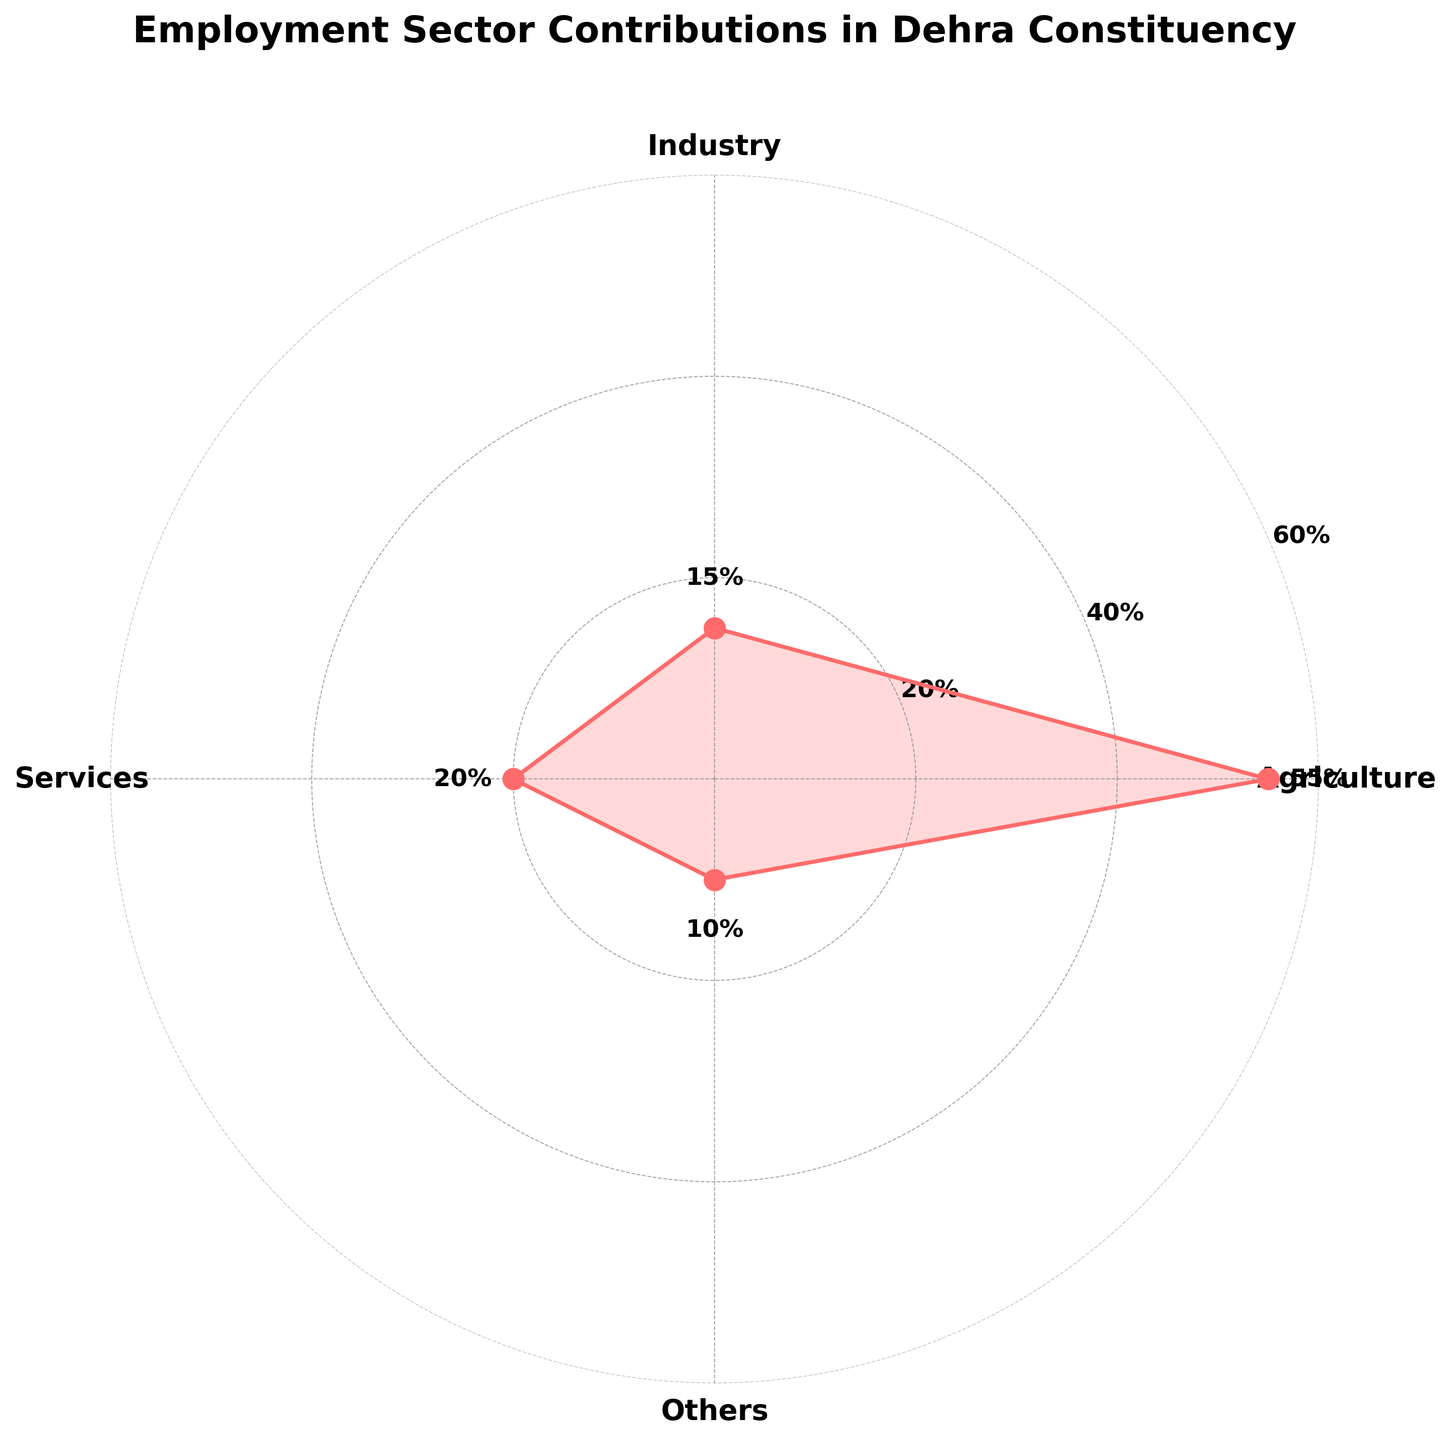What is the title of the polar chart? The title of the chart is displayed at the top in bold and larger font, which describes what the chart is about.
Answer: Employment Sector Contributions in Dehra Constituency Which sector has the largest contribution? Look at the labels around the polar chart and identify the one where the percentage is the highest.
Answer: Agriculture What is the percentage contribution of the 'Services' sector? Find the 'Services' label on the chart and read the corresponding percentage value next to it.
Answer: 20% How do the contributions of 'Industry' and 'Others' compare? Find both 'Industry' and 'Others' labels and compare their respective percentage values.
Answer: Industry (15%) is greater than Others (10%) What is the difference between the contributions of 'Agriculture' and 'Services' sectors? Subtract the percentage of the 'Services' sector from the percentage of the 'Agriculture' sector.
Answer: 55% - 20% = 35% What is the average percentage contribution across all sectors? Add up the percentages of all sectors and divide by the number of sectors: (55 + 15 + 20 + 10)/4.
Answer: 100 / 4 = 25% What is the combined percentage contribution of 'Industry' and 'Others'? Sum the percentage contributions of 'Industry' and 'Others' sectors.
Answer: 15% + 10% = 25% How many sectors contribute more than 10%? Identify sectors whose percentage contributions are greater than 10%. Count them.
Answer: Three sectors (Agriculture, Industry, Services) Is the 'Agriculture' sector's contribution more than half of the total contributions? The total contribution is 100%. Check if 55% (Agriculture) is more than 50%.
Answer: Yes, it is more than half 